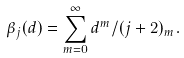<formula> <loc_0><loc_0><loc_500><loc_500>\beta _ { j } ( d ) = \sum _ { m = 0 } ^ { \infty } d ^ { m } / ( j + 2 ) _ { m } .</formula> 